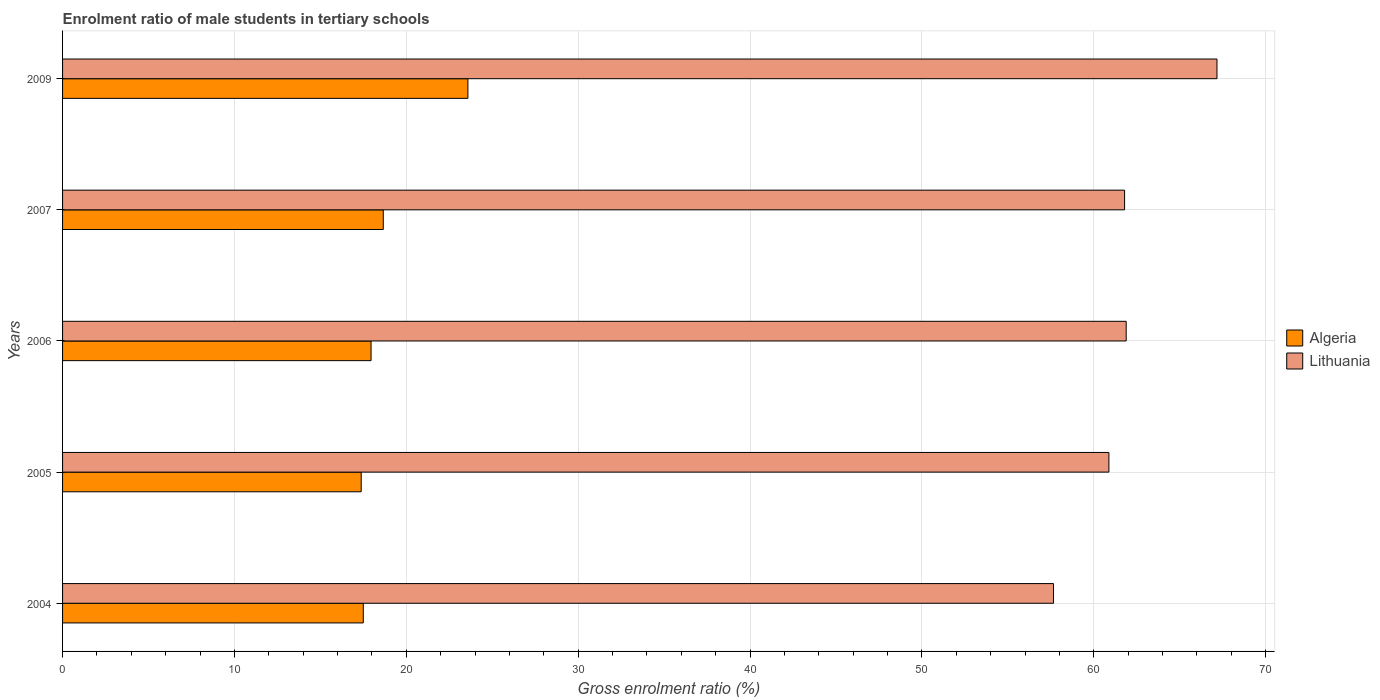How many groups of bars are there?
Ensure brevity in your answer.  5. Are the number of bars per tick equal to the number of legend labels?
Provide a short and direct response. Yes. Are the number of bars on each tick of the Y-axis equal?
Ensure brevity in your answer.  Yes. How many bars are there on the 5th tick from the top?
Provide a short and direct response. 2. In how many cases, is the number of bars for a given year not equal to the number of legend labels?
Your answer should be very brief. 0. What is the enrolment ratio of male students in tertiary schools in Lithuania in 2005?
Give a very brief answer. 60.88. Across all years, what is the maximum enrolment ratio of male students in tertiary schools in Lithuania?
Give a very brief answer. 67.17. Across all years, what is the minimum enrolment ratio of male students in tertiary schools in Algeria?
Offer a terse response. 17.38. In which year was the enrolment ratio of male students in tertiary schools in Lithuania maximum?
Ensure brevity in your answer.  2009. In which year was the enrolment ratio of male students in tertiary schools in Algeria minimum?
Give a very brief answer. 2005. What is the total enrolment ratio of male students in tertiary schools in Algeria in the graph?
Keep it short and to the point. 95.06. What is the difference between the enrolment ratio of male students in tertiary schools in Algeria in 2004 and that in 2005?
Give a very brief answer. 0.12. What is the difference between the enrolment ratio of male students in tertiary schools in Lithuania in 2005 and the enrolment ratio of male students in tertiary schools in Algeria in 2009?
Provide a succinct answer. 37.29. What is the average enrolment ratio of male students in tertiary schools in Algeria per year?
Offer a very short reply. 19.01. In the year 2009, what is the difference between the enrolment ratio of male students in tertiary schools in Algeria and enrolment ratio of male students in tertiary schools in Lithuania?
Offer a very short reply. -43.58. In how many years, is the enrolment ratio of male students in tertiary schools in Algeria greater than 22 %?
Make the answer very short. 1. What is the ratio of the enrolment ratio of male students in tertiary schools in Algeria in 2004 to that in 2006?
Offer a terse response. 0.97. Is the difference between the enrolment ratio of male students in tertiary schools in Algeria in 2005 and 2009 greater than the difference between the enrolment ratio of male students in tertiary schools in Lithuania in 2005 and 2009?
Provide a short and direct response. Yes. What is the difference between the highest and the second highest enrolment ratio of male students in tertiary schools in Lithuania?
Offer a terse response. 5.28. What is the difference between the highest and the lowest enrolment ratio of male students in tertiary schools in Lithuania?
Your answer should be compact. 9.51. In how many years, is the enrolment ratio of male students in tertiary schools in Lithuania greater than the average enrolment ratio of male students in tertiary schools in Lithuania taken over all years?
Give a very brief answer. 2. What does the 2nd bar from the top in 2009 represents?
Your answer should be very brief. Algeria. What does the 2nd bar from the bottom in 2007 represents?
Provide a short and direct response. Lithuania. How many bars are there?
Your response must be concise. 10. Are all the bars in the graph horizontal?
Offer a terse response. Yes. What is the difference between two consecutive major ticks on the X-axis?
Give a very brief answer. 10. What is the title of the graph?
Offer a terse response. Enrolment ratio of male students in tertiary schools. Does "Mali" appear as one of the legend labels in the graph?
Give a very brief answer. No. What is the label or title of the X-axis?
Provide a short and direct response. Gross enrolment ratio (%). What is the Gross enrolment ratio (%) in Algeria in 2004?
Make the answer very short. 17.5. What is the Gross enrolment ratio (%) of Lithuania in 2004?
Keep it short and to the point. 57.66. What is the Gross enrolment ratio (%) in Algeria in 2005?
Your answer should be very brief. 17.38. What is the Gross enrolment ratio (%) of Lithuania in 2005?
Keep it short and to the point. 60.88. What is the Gross enrolment ratio (%) in Algeria in 2006?
Offer a very short reply. 17.95. What is the Gross enrolment ratio (%) of Lithuania in 2006?
Your answer should be very brief. 61.88. What is the Gross enrolment ratio (%) of Algeria in 2007?
Your response must be concise. 18.66. What is the Gross enrolment ratio (%) of Lithuania in 2007?
Keep it short and to the point. 61.79. What is the Gross enrolment ratio (%) in Algeria in 2009?
Give a very brief answer. 23.58. What is the Gross enrolment ratio (%) of Lithuania in 2009?
Provide a short and direct response. 67.17. Across all years, what is the maximum Gross enrolment ratio (%) of Algeria?
Offer a very short reply. 23.58. Across all years, what is the maximum Gross enrolment ratio (%) in Lithuania?
Provide a short and direct response. 67.17. Across all years, what is the minimum Gross enrolment ratio (%) in Algeria?
Ensure brevity in your answer.  17.38. Across all years, what is the minimum Gross enrolment ratio (%) in Lithuania?
Your response must be concise. 57.66. What is the total Gross enrolment ratio (%) in Algeria in the graph?
Your answer should be compact. 95.06. What is the total Gross enrolment ratio (%) of Lithuania in the graph?
Give a very brief answer. 309.37. What is the difference between the Gross enrolment ratio (%) of Algeria in 2004 and that in 2005?
Keep it short and to the point. 0.12. What is the difference between the Gross enrolment ratio (%) of Lithuania in 2004 and that in 2005?
Make the answer very short. -3.22. What is the difference between the Gross enrolment ratio (%) of Algeria in 2004 and that in 2006?
Provide a short and direct response. -0.45. What is the difference between the Gross enrolment ratio (%) of Lithuania in 2004 and that in 2006?
Keep it short and to the point. -4.23. What is the difference between the Gross enrolment ratio (%) of Algeria in 2004 and that in 2007?
Offer a terse response. -1.16. What is the difference between the Gross enrolment ratio (%) of Lithuania in 2004 and that in 2007?
Keep it short and to the point. -4.14. What is the difference between the Gross enrolment ratio (%) of Algeria in 2004 and that in 2009?
Offer a very short reply. -6.09. What is the difference between the Gross enrolment ratio (%) in Lithuania in 2004 and that in 2009?
Offer a very short reply. -9.51. What is the difference between the Gross enrolment ratio (%) of Algeria in 2005 and that in 2006?
Offer a very short reply. -0.57. What is the difference between the Gross enrolment ratio (%) of Lithuania in 2005 and that in 2006?
Keep it short and to the point. -1.01. What is the difference between the Gross enrolment ratio (%) in Algeria in 2005 and that in 2007?
Ensure brevity in your answer.  -1.28. What is the difference between the Gross enrolment ratio (%) of Lithuania in 2005 and that in 2007?
Offer a terse response. -0.91. What is the difference between the Gross enrolment ratio (%) of Algeria in 2005 and that in 2009?
Your answer should be very brief. -6.21. What is the difference between the Gross enrolment ratio (%) of Lithuania in 2005 and that in 2009?
Keep it short and to the point. -6.29. What is the difference between the Gross enrolment ratio (%) in Algeria in 2006 and that in 2007?
Keep it short and to the point. -0.71. What is the difference between the Gross enrolment ratio (%) in Lithuania in 2006 and that in 2007?
Your answer should be very brief. 0.09. What is the difference between the Gross enrolment ratio (%) of Algeria in 2006 and that in 2009?
Give a very brief answer. -5.63. What is the difference between the Gross enrolment ratio (%) in Lithuania in 2006 and that in 2009?
Offer a very short reply. -5.28. What is the difference between the Gross enrolment ratio (%) in Algeria in 2007 and that in 2009?
Offer a very short reply. -4.92. What is the difference between the Gross enrolment ratio (%) in Lithuania in 2007 and that in 2009?
Your answer should be very brief. -5.38. What is the difference between the Gross enrolment ratio (%) in Algeria in 2004 and the Gross enrolment ratio (%) in Lithuania in 2005?
Offer a terse response. -43.38. What is the difference between the Gross enrolment ratio (%) of Algeria in 2004 and the Gross enrolment ratio (%) of Lithuania in 2006?
Offer a terse response. -44.39. What is the difference between the Gross enrolment ratio (%) of Algeria in 2004 and the Gross enrolment ratio (%) of Lithuania in 2007?
Your answer should be compact. -44.29. What is the difference between the Gross enrolment ratio (%) in Algeria in 2004 and the Gross enrolment ratio (%) in Lithuania in 2009?
Provide a short and direct response. -49.67. What is the difference between the Gross enrolment ratio (%) in Algeria in 2005 and the Gross enrolment ratio (%) in Lithuania in 2006?
Provide a short and direct response. -44.51. What is the difference between the Gross enrolment ratio (%) of Algeria in 2005 and the Gross enrolment ratio (%) of Lithuania in 2007?
Give a very brief answer. -44.42. What is the difference between the Gross enrolment ratio (%) of Algeria in 2005 and the Gross enrolment ratio (%) of Lithuania in 2009?
Your answer should be very brief. -49.79. What is the difference between the Gross enrolment ratio (%) in Algeria in 2006 and the Gross enrolment ratio (%) in Lithuania in 2007?
Your answer should be very brief. -43.84. What is the difference between the Gross enrolment ratio (%) of Algeria in 2006 and the Gross enrolment ratio (%) of Lithuania in 2009?
Offer a terse response. -49.22. What is the difference between the Gross enrolment ratio (%) in Algeria in 2007 and the Gross enrolment ratio (%) in Lithuania in 2009?
Your answer should be compact. -48.51. What is the average Gross enrolment ratio (%) in Algeria per year?
Your answer should be very brief. 19.01. What is the average Gross enrolment ratio (%) of Lithuania per year?
Provide a succinct answer. 61.87. In the year 2004, what is the difference between the Gross enrolment ratio (%) of Algeria and Gross enrolment ratio (%) of Lithuania?
Offer a very short reply. -40.16. In the year 2005, what is the difference between the Gross enrolment ratio (%) of Algeria and Gross enrolment ratio (%) of Lithuania?
Give a very brief answer. -43.5. In the year 2006, what is the difference between the Gross enrolment ratio (%) of Algeria and Gross enrolment ratio (%) of Lithuania?
Keep it short and to the point. -43.93. In the year 2007, what is the difference between the Gross enrolment ratio (%) of Algeria and Gross enrolment ratio (%) of Lithuania?
Provide a short and direct response. -43.13. In the year 2009, what is the difference between the Gross enrolment ratio (%) of Algeria and Gross enrolment ratio (%) of Lithuania?
Provide a short and direct response. -43.58. What is the ratio of the Gross enrolment ratio (%) in Algeria in 2004 to that in 2005?
Ensure brevity in your answer.  1.01. What is the ratio of the Gross enrolment ratio (%) in Lithuania in 2004 to that in 2005?
Make the answer very short. 0.95. What is the ratio of the Gross enrolment ratio (%) in Algeria in 2004 to that in 2006?
Offer a very short reply. 0.97. What is the ratio of the Gross enrolment ratio (%) of Lithuania in 2004 to that in 2006?
Your answer should be very brief. 0.93. What is the ratio of the Gross enrolment ratio (%) in Algeria in 2004 to that in 2007?
Provide a succinct answer. 0.94. What is the ratio of the Gross enrolment ratio (%) in Lithuania in 2004 to that in 2007?
Your answer should be compact. 0.93. What is the ratio of the Gross enrolment ratio (%) of Algeria in 2004 to that in 2009?
Provide a short and direct response. 0.74. What is the ratio of the Gross enrolment ratio (%) in Lithuania in 2004 to that in 2009?
Make the answer very short. 0.86. What is the ratio of the Gross enrolment ratio (%) of Algeria in 2005 to that in 2006?
Your response must be concise. 0.97. What is the ratio of the Gross enrolment ratio (%) of Lithuania in 2005 to that in 2006?
Your answer should be very brief. 0.98. What is the ratio of the Gross enrolment ratio (%) in Algeria in 2005 to that in 2007?
Keep it short and to the point. 0.93. What is the ratio of the Gross enrolment ratio (%) of Lithuania in 2005 to that in 2007?
Give a very brief answer. 0.99. What is the ratio of the Gross enrolment ratio (%) in Algeria in 2005 to that in 2009?
Your answer should be very brief. 0.74. What is the ratio of the Gross enrolment ratio (%) in Lithuania in 2005 to that in 2009?
Ensure brevity in your answer.  0.91. What is the ratio of the Gross enrolment ratio (%) of Algeria in 2006 to that in 2007?
Offer a very short reply. 0.96. What is the ratio of the Gross enrolment ratio (%) in Algeria in 2006 to that in 2009?
Ensure brevity in your answer.  0.76. What is the ratio of the Gross enrolment ratio (%) in Lithuania in 2006 to that in 2009?
Keep it short and to the point. 0.92. What is the ratio of the Gross enrolment ratio (%) in Algeria in 2007 to that in 2009?
Your response must be concise. 0.79. What is the difference between the highest and the second highest Gross enrolment ratio (%) in Algeria?
Make the answer very short. 4.92. What is the difference between the highest and the second highest Gross enrolment ratio (%) in Lithuania?
Keep it short and to the point. 5.28. What is the difference between the highest and the lowest Gross enrolment ratio (%) of Algeria?
Keep it short and to the point. 6.21. What is the difference between the highest and the lowest Gross enrolment ratio (%) of Lithuania?
Provide a short and direct response. 9.51. 